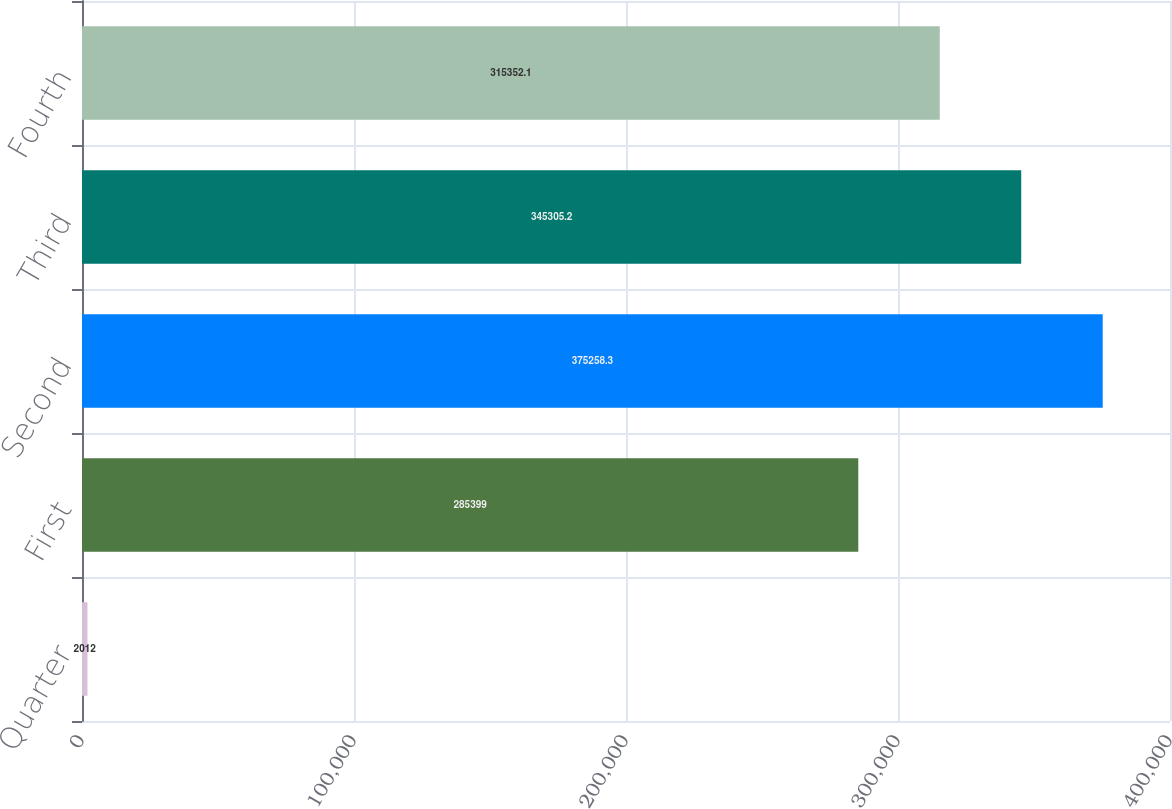Convert chart to OTSL. <chart><loc_0><loc_0><loc_500><loc_500><bar_chart><fcel>Quarter<fcel>First<fcel>Second<fcel>Third<fcel>Fourth<nl><fcel>2012<fcel>285399<fcel>375258<fcel>345305<fcel>315352<nl></chart> 